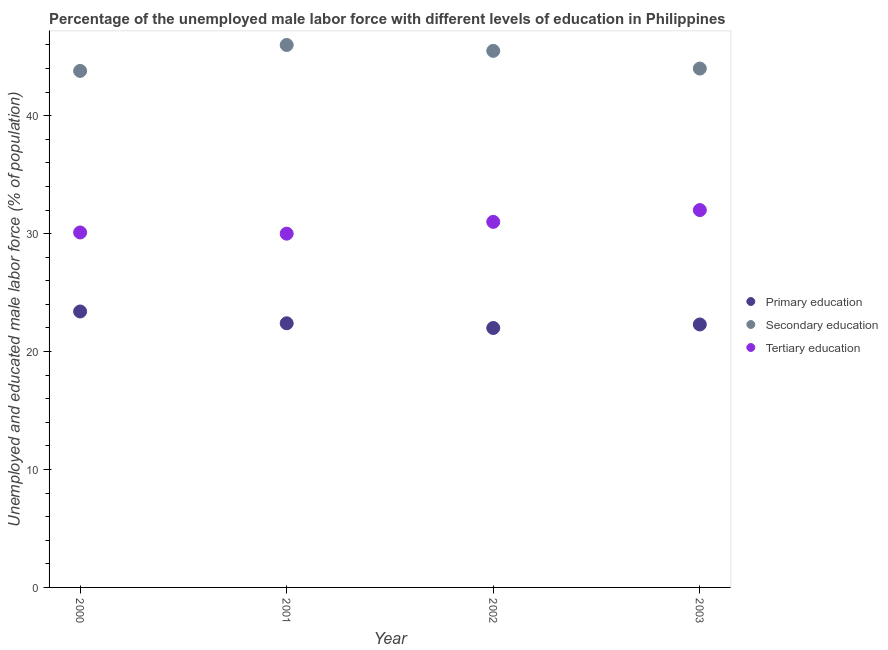How many different coloured dotlines are there?
Make the answer very short. 3. In which year was the percentage of male labor force who received primary education minimum?
Give a very brief answer. 2002. What is the total percentage of male labor force who received tertiary education in the graph?
Offer a very short reply. 123.1. What is the difference between the percentage of male labor force who received secondary education in 2002 and that in 2003?
Offer a terse response. 1.5. What is the difference between the percentage of male labor force who received primary education in 2001 and the percentage of male labor force who received tertiary education in 2002?
Offer a terse response. -8.6. What is the average percentage of male labor force who received primary education per year?
Your answer should be compact. 22.52. In the year 2001, what is the difference between the percentage of male labor force who received primary education and percentage of male labor force who received tertiary education?
Ensure brevity in your answer.  -7.6. In how many years, is the percentage of male labor force who received secondary education greater than 40 %?
Ensure brevity in your answer.  4. What is the ratio of the percentage of male labor force who received tertiary education in 2000 to that in 2001?
Provide a short and direct response. 1. Is the percentage of male labor force who received tertiary education in 2000 less than that in 2002?
Offer a terse response. Yes. What is the difference between the highest and the second highest percentage of male labor force who received tertiary education?
Offer a terse response. 1. What is the difference between the highest and the lowest percentage of male labor force who received primary education?
Give a very brief answer. 1.4. Does the percentage of male labor force who received primary education monotonically increase over the years?
Offer a terse response. No. Is the percentage of male labor force who received primary education strictly less than the percentage of male labor force who received secondary education over the years?
Your answer should be compact. Yes. How many dotlines are there?
Offer a very short reply. 3. How many years are there in the graph?
Provide a succinct answer. 4. What is the difference between two consecutive major ticks on the Y-axis?
Offer a very short reply. 10. Does the graph contain grids?
Give a very brief answer. No. Where does the legend appear in the graph?
Offer a very short reply. Center right. How many legend labels are there?
Your response must be concise. 3. What is the title of the graph?
Offer a terse response. Percentage of the unemployed male labor force with different levels of education in Philippines. Does "Services" appear as one of the legend labels in the graph?
Make the answer very short. No. What is the label or title of the X-axis?
Make the answer very short. Year. What is the label or title of the Y-axis?
Offer a very short reply. Unemployed and educated male labor force (% of population). What is the Unemployed and educated male labor force (% of population) of Primary education in 2000?
Make the answer very short. 23.4. What is the Unemployed and educated male labor force (% of population) in Secondary education in 2000?
Your answer should be very brief. 43.8. What is the Unemployed and educated male labor force (% of population) in Tertiary education in 2000?
Make the answer very short. 30.1. What is the Unemployed and educated male labor force (% of population) in Primary education in 2001?
Give a very brief answer. 22.4. What is the Unemployed and educated male labor force (% of population) in Secondary education in 2001?
Give a very brief answer. 46. What is the Unemployed and educated male labor force (% of population) of Secondary education in 2002?
Offer a very short reply. 45.5. What is the Unemployed and educated male labor force (% of population) of Tertiary education in 2002?
Offer a very short reply. 31. What is the Unemployed and educated male labor force (% of population) in Primary education in 2003?
Keep it short and to the point. 22.3. What is the Unemployed and educated male labor force (% of population) in Secondary education in 2003?
Ensure brevity in your answer.  44. What is the Unemployed and educated male labor force (% of population) in Tertiary education in 2003?
Your response must be concise. 32. Across all years, what is the maximum Unemployed and educated male labor force (% of population) of Primary education?
Provide a short and direct response. 23.4. Across all years, what is the maximum Unemployed and educated male labor force (% of population) in Tertiary education?
Make the answer very short. 32. Across all years, what is the minimum Unemployed and educated male labor force (% of population) in Secondary education?
Offer a very short reply. 43.8. What is the total Unemployed and educated male labor force (% of population) in Primary education in the graph?
Offer a terse response. 90.1. What is the total Unemployed and educated male labor force (% of population) in Secondary education in the graph?
Keep it short and to the point. 179.3. What is the total Unemployed and educated male labor force (% of population) in Tertiary education in the graph?
Offer a terse response. 123.1. What is the difference between the Unemployed and educated male labor force (% of population) of Primary education in 2000 and that in 2001?
Give a very brief answer. 1. What is the difference between the Unemployed and educated male labor force (% of population) of Secondary education in 2000 and that in 2001?
Your answer should be very brief. -2.2. What is the difference between the Unemployed and educated male labor force (% of population) of Tertiary education in 2000 and that in 2001?
Your answer should be compact. 0.1. What is the difference between the Unemployed and educated male labor force (% of population) of Primary education in 2000 and that in 2003?
Offer a terse response. 1.1. What is the difference between the Unemployed and educated male labor force (% of population) of Tertiary education in 2000 and that in 2003?
Your answer should be very brief. -1.9. What is the difference between the Unemployed and educated male labor force (% of population) in Secondary education in 2001 and that in 2002?
Your answer should be compact. 0.5. What is the difference between the Unemployed and educated male labor force (% of population) of Primary education in 2001 and that in 2003?
Provide a short and direct response. 0.1. What is the difference between the Unemployed and educated male labor force (% of population) of Secondary education in 2001 and that in 2003?
Provide a succinct answer. 2. What is the difference between the Unemployed and educated male labor force (% of population) of Secondary education in 2002 and that in 2003?
Provide a succinct answer. 1.5. What is the difference between the Unemployed and educated male labor force (% of population) in Primary education in 2000 and the Unemployed and educated male labor force (% of population) in Secondary education in 2001?
Provide a short and direct response. -22.6. What is the difference between the Unemployed and educated male labor force (% of population) of Secondary education in 2000 and the Unemployed and educated male labor force (% of population) of Tertiary education in 2001?
Your response must be concise. 13.8. What is the difference between the Unemployed and educated male labor force (% of population) of Primary education in 2000 and the Unemployed and educated male labor force (% of population) of Secondary education in 2002?
Your answer should be compact. -22.1. What is the difference between the Unemployed and educated male labor force (% of population) of Primary education in 2000 and the Unemployed and educated male labor force (% of population) of Secondary education in 2003?
Offer a very short reply. -20.6. What is the difference between the Unemployed and educated male labor force (% of population) in Primary education in 2001 and the Unemployed and educated male labor force (% of population) in Secondary education in 2002?
Give a very brief answer. -23.1. What is the difference between the Unemployed and educated male labor force (% of population) in Secondary education in 2001 and the Unemployed and educated male labor force (% of population) in Tertiary education in 2002?
Offer a terse response. 15. What is the difference between the Unemployed and educated male labor force (% of population) in Primary education in 2001 and the Unemployed and educated male labor force (% of population) in Secondary education in 2003?
Give a very brief answer. -21.6. What is the difference between the Unemployed and educated male labor force (% of population) in Primary education in 2001 and the Unemployed and educated male labor force (% of population) in Tertiary education in 2003?
Give a very brief answer. -9.6. What is the difference between the Unemployed and educated male labor force (% of population) of Primary education in 2002 and the Unemployed and educated male labor force (% of population) of Secondary education in 2003?
Provide a succinct answer. -22. What is the difference between the Unemployed and educated male labor force (% of population) of Primary education in 2002 and the Unemployed and educated male labor force (% of population) of Tertiary education in 2003?
Make the answer very short. -10. What is the difference between the Unemployed and educated male labor force (% of population) of Secondary education in 2002 and the Unemployed and educated male labor force (% of population) of Tertiary education in 2003?
Your answer should be very brief. 13.5. What is the average Unemployed and educated male labor force (% of population) in Primary education per year?
Ensure brevity in your answer.  22.52. What is the average Unemployed and educated male labor force (% of population) in Secondary education per year?
Make the answer very short. 44.83. What is the average Unemployed and educated male labor force (% of population) of Tertiary education per year?
Make the answer very short. 30.77. In the year 2000, what is the difference between the Unemployed and educated male labor force (% of population) of Primary education and Unemployed and educated male labor force (% of population) of Secondary education?
Make the answer very short. -20.4. In the year 2001, what is the difference between the Unemployed and educated male labor force (% of population) in Primary education and Unemployed and educated male labor force (% of population) in Secondary education?
Your answer should be compact. -23.6. In the year 2001, what is the difference between the Unemployed and educated male labor force (% of population) of Primary education and Unemployed and educated male labor force (% of population) of Tertiary education?
Provide a short and direct response. -7.6. In the year 2002, what is the difference between the Unemployed and educated male labor force (% of population) in Primary education and Unemployed and educated male labor force (% of population) in Secondary education?
Give a very brief answer. -23.5. In the year 2003, what is the difference between the Unemployed and educated male labor force (% of population) of Primary education and Unemployed and educated male labor force (% of population) of Secondary education?
Give a very brief answer. -21.7. In the year 2003, what is the difference between the Unemployed and educated male labor force (% of population) in Primary education and Unemployed and educated male labor force (% of population) in Tertiary education?
Keep it short and to the point. -9.7. In the year 2003, what is the difference between the Unemployed and educated male labor force (% of population) in Secondary education and Unemployed and educated male labor force (% of population) in Tertiary education?
Ensure brevity in your answer.  12. What is the ratio of the Unemployed and educated male labor force (% of population) in Primary education in 2000 to that in 2001?
Give a very brief answer. 1.04. What is the ratio of the Unemployed and educated male labor force (% of population) in Secondary education in 2000 to that in 2001?
Provide a succinct answer. 0.95. What is the ratio of the Unemployed and educated male labor force (% of population) of Primary education in 2000 to that in 2002?
Ensure brevity in your answer.  1.06. What is the ratio of the Unemployed and educated male labor force (% of population) in Secondary education in 2000 to that in 2002?
Make the answer very short. 0.96. What is the ratio of the Unemployed and educated male labor force (% of population) in Primary education in 2000 to that in 2003?
Your response must be concise. 1.05. What is the ratio of the Unemployed and educated male labor force (% of population) of Tertiary education in 2000 to that in 2003?
Provide a succinct answer. 0.94. What is the ratio of the Unemployed and educated male labor force (% of population) in Primary education in 2001 to that in 2002?
Give a very brief answer. 1.02. What is the ratio of the Unemployed and educated male labor force (% of population) in Primary education in 2001 to that in 2003?
Offer a terse response. 1. What is the ratio of the Unemployed and educated male labor force (% of population) in Secondary education in 2001 to that in 2003?
Offer a terse response. 1.05. What is the ratio of the Unemployed and educated male labor force (% of population) in Tertiary education in 2001 to that in 2003?
Provide a succinct answer. 0.94. What is the ratio of the Unemployed and educated male labor force (% of population) of Primary education in 2002 to that in 2003?
Offer a very short reply. 0.99. What is the ratio of the Unemployed and educated male labor force (% of population) in Secondary education in 2002 to that in 2003?
Your answer should be compact. 1.03. What is the ratio of the Unemployed and educated male labor force (% of population) of Tertiary education in 2002 to that in 2003?
Your response must be concise. 0.97. What is the difference between the highest and the lowest Unemployed and educated male labor force (% of population) of Primary education?
Provide a succinct answer. 1.4. What is the difference between the highest and the lowest Unemployed and educated male labor force (% of population) in Secondary education?
Your response must be concise. 2.2. 